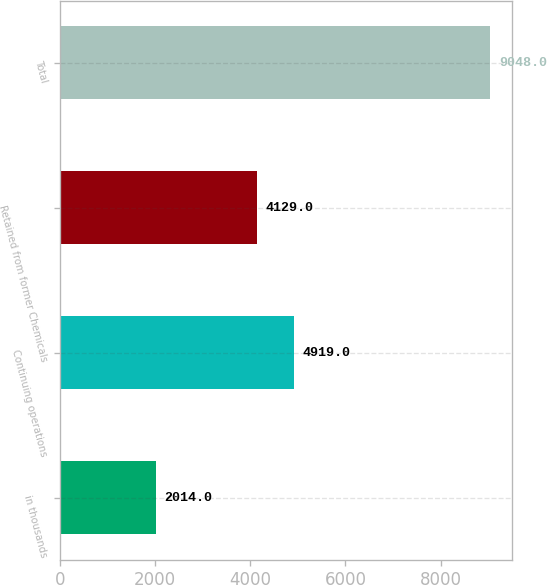Convert chart to OTSL. <chart><loc_0><loc_0><loc_500><loc_500><bar_chart><fcel>in thousands<fcel>Continuing operations<fcel>Retained from former Chemicals<fcel>Total<nl><fcel>2014<fcel>4919<fcel>4129<fcel>9048<nl></chart> 